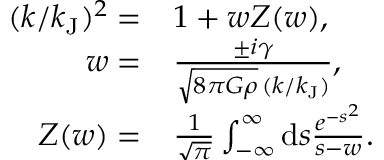Convert formula to latex. <formula><loc_0><loc_0><loc_500><loc_500>\begin{array} { r l } { ( k / k _ { J } ) ^ { 2 } = } & { 1 + w Z ( w ) , } \\ { w = } & { \frac { \pm i \gamma } { \sqrt { 8 \pi G \rho } \, ( k / k _ { J } ) } , } \\ { Z ( w ) = } & { \frac { 1 } { \sqrt { \pi } } \int _ { - \infty } ^ { \infty } d s \frac { e ^ { - s ^ { 2 } } } { s - w } . } \end{array}</formula> 